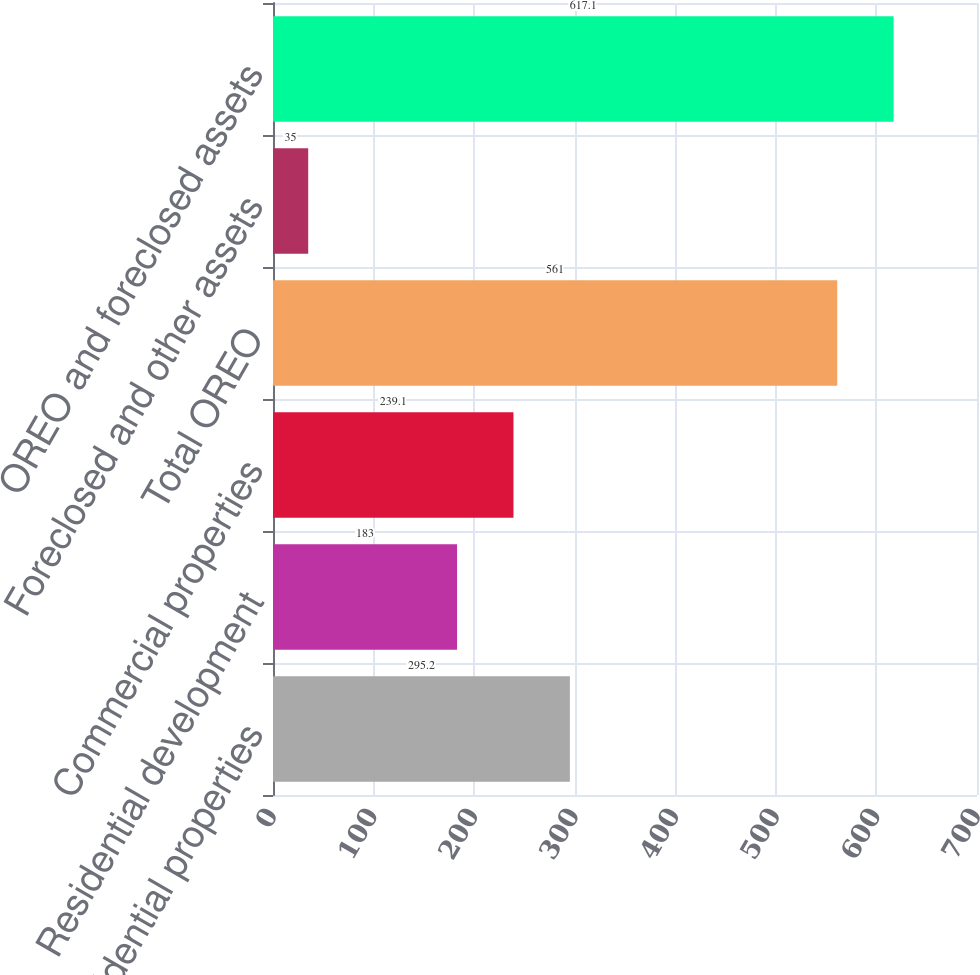<chart> <loc_0><loc_0><loc_500><loc_500><bar_chart><fcel>Residential properties<fcel>Residential development<fcel>Commercial properties<fcel>Total OREO<fcel>Foreclosed and other assets<fcel>OREO and foreclosed assets<nl><fcel>295.2<fcel>183<fcel>239.1<fcel>561<fcel>35<fcel>617.1<nl></chart> 